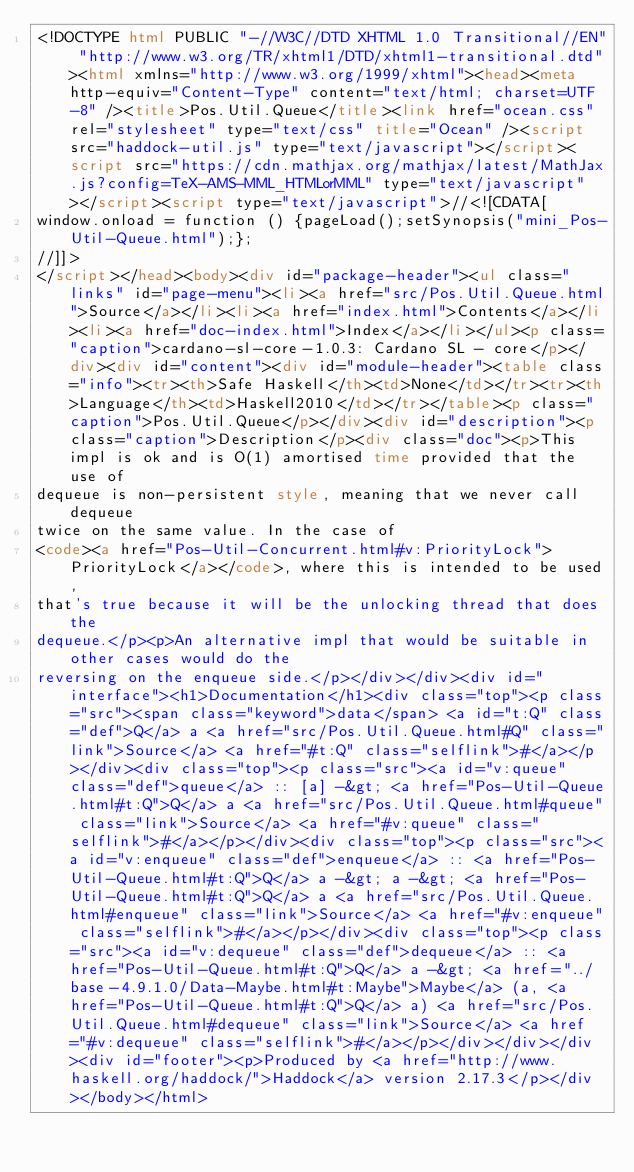Convert code to text. <code><loc_0><loc_0><loc_500><loc_500><_HTML_><!DOCTYPE html PUBLIC "-//W3C//DTD XHTML 1.0 Transitional//EN" "http://www.w3.org/TR/xhtml1/DTD/xhtml1-transitional.dtd"><html xmlns="http://www.w3.org/1999/xhtml"><head><meta http-equiv="Content-Type" content="text/html; charset=UTF-8" /><title>Pos.Util.Queue</title><link href="ocean.css" rel="stylesheet" type="text/css" title="Ocean" /><script src="haddock-util.js" type="text/javascript"></script><script src="https://cdn.mathjax.org/mathjax/latest/MathJax.js?config=TeX-AMS-MML_HTMLorMML" type="text/javascript"></script><script type="text/javascript">//<![CDATA[
window.onload = function () {pageLoad();setSynopsis("mini_Pos-Util-Queue.html");};
//]]>
</script></head><body><div id="package-header"><ul class="links" id="page-menu"><li><a href="src/Pos.Util.Queue.html">Source</a></li><li><a href="index.html">Contents</a></li><li><a href="doc-index.html">Index</a></li></ul><p class="caption">cardano-sl-core-1.0.3: Cardano SL - core</p></div><div id="content"><div id="module-header"><table class="info"><tr><th>Safe Haskell</th><td>None</td></tr><tr><th>Language</th><td>Haskell2010</td></tr></table><p class="caption">Pos.Util.Queue</p></div><div id="description"><p class="caption">Description</p><div class="doc"><p>This impl is ok and is O(1) amortised time provided that the use of
dequeue is non-persistent style, meaning that we never call dequeue
twice on the same value. In the case of
<code><a href="Pos-Util-Concurrent.html#v:PriorityLock">PriorityLock</a></code>, where this is intended to be used,
that's true because it will be the unlocking thread that does the
dequeue.</p><p>An alternative impl that would be suitable in other cases would do the
reversing on the enqueue side.</p></div></div><div id="interface"><h1>Documentation</h1><div class="top"><p class="src"><span class="keyword">data</span> <a id="t:Q" class="def">Q</a> a <a href="src/Pos.Util.Queue.html#Q" class="link">Source</a> <a href="#t:Q" class="selflink">#</a></p></div><div class="top"><p class="src"><a id="v:queue" class="def">queue</a> :: [a] -&gt; <a href="Pos-Util-Queue.html#t:Q">Q</a> a <a href="src/Pos.Util.Queue.html#queue" class="link">Source</a> <a href="#v:queue" class="selflink">#</a></p></div><div class="top"><p class="src"><a id="v:enqueue" class="def">enqueue</a> :: <a href="Pos-Util-Queue.html#t:Q">Q</a> a -&gt; a -&gt; <a href="Pos-Util-Queue.html#t:Q">Q</a> a <a href="src/Pos.Util.Queue.html#enqueue" class="link">Source</a> <a href="#v:enqueue" class="selflink">#</a></p></div><div class="top"><p class="src"><a id="v:dequeue" class="def">dequeue</a> :: <a href="Pos-Util-Queue.html#t:Q">Q</a> a -&gt; <a href="../base-4.9.1.0/Data-Maybe.html#t:Maybe">Maybe</a> (a, <a href="Pos-Util-Queue.html#t:Q">Q</a> a) <a href="src/Pos.Util.Queue.html#dequeue" class="link">Source</a> <a href="#v:dequeue" class="selflink">#</a></p></div></div></div><div id="footer"><p>Produced by <a href="http://www.haskell.org/haddock/">Haddock</a> version 2.17.3</p></div></body></html></code> 